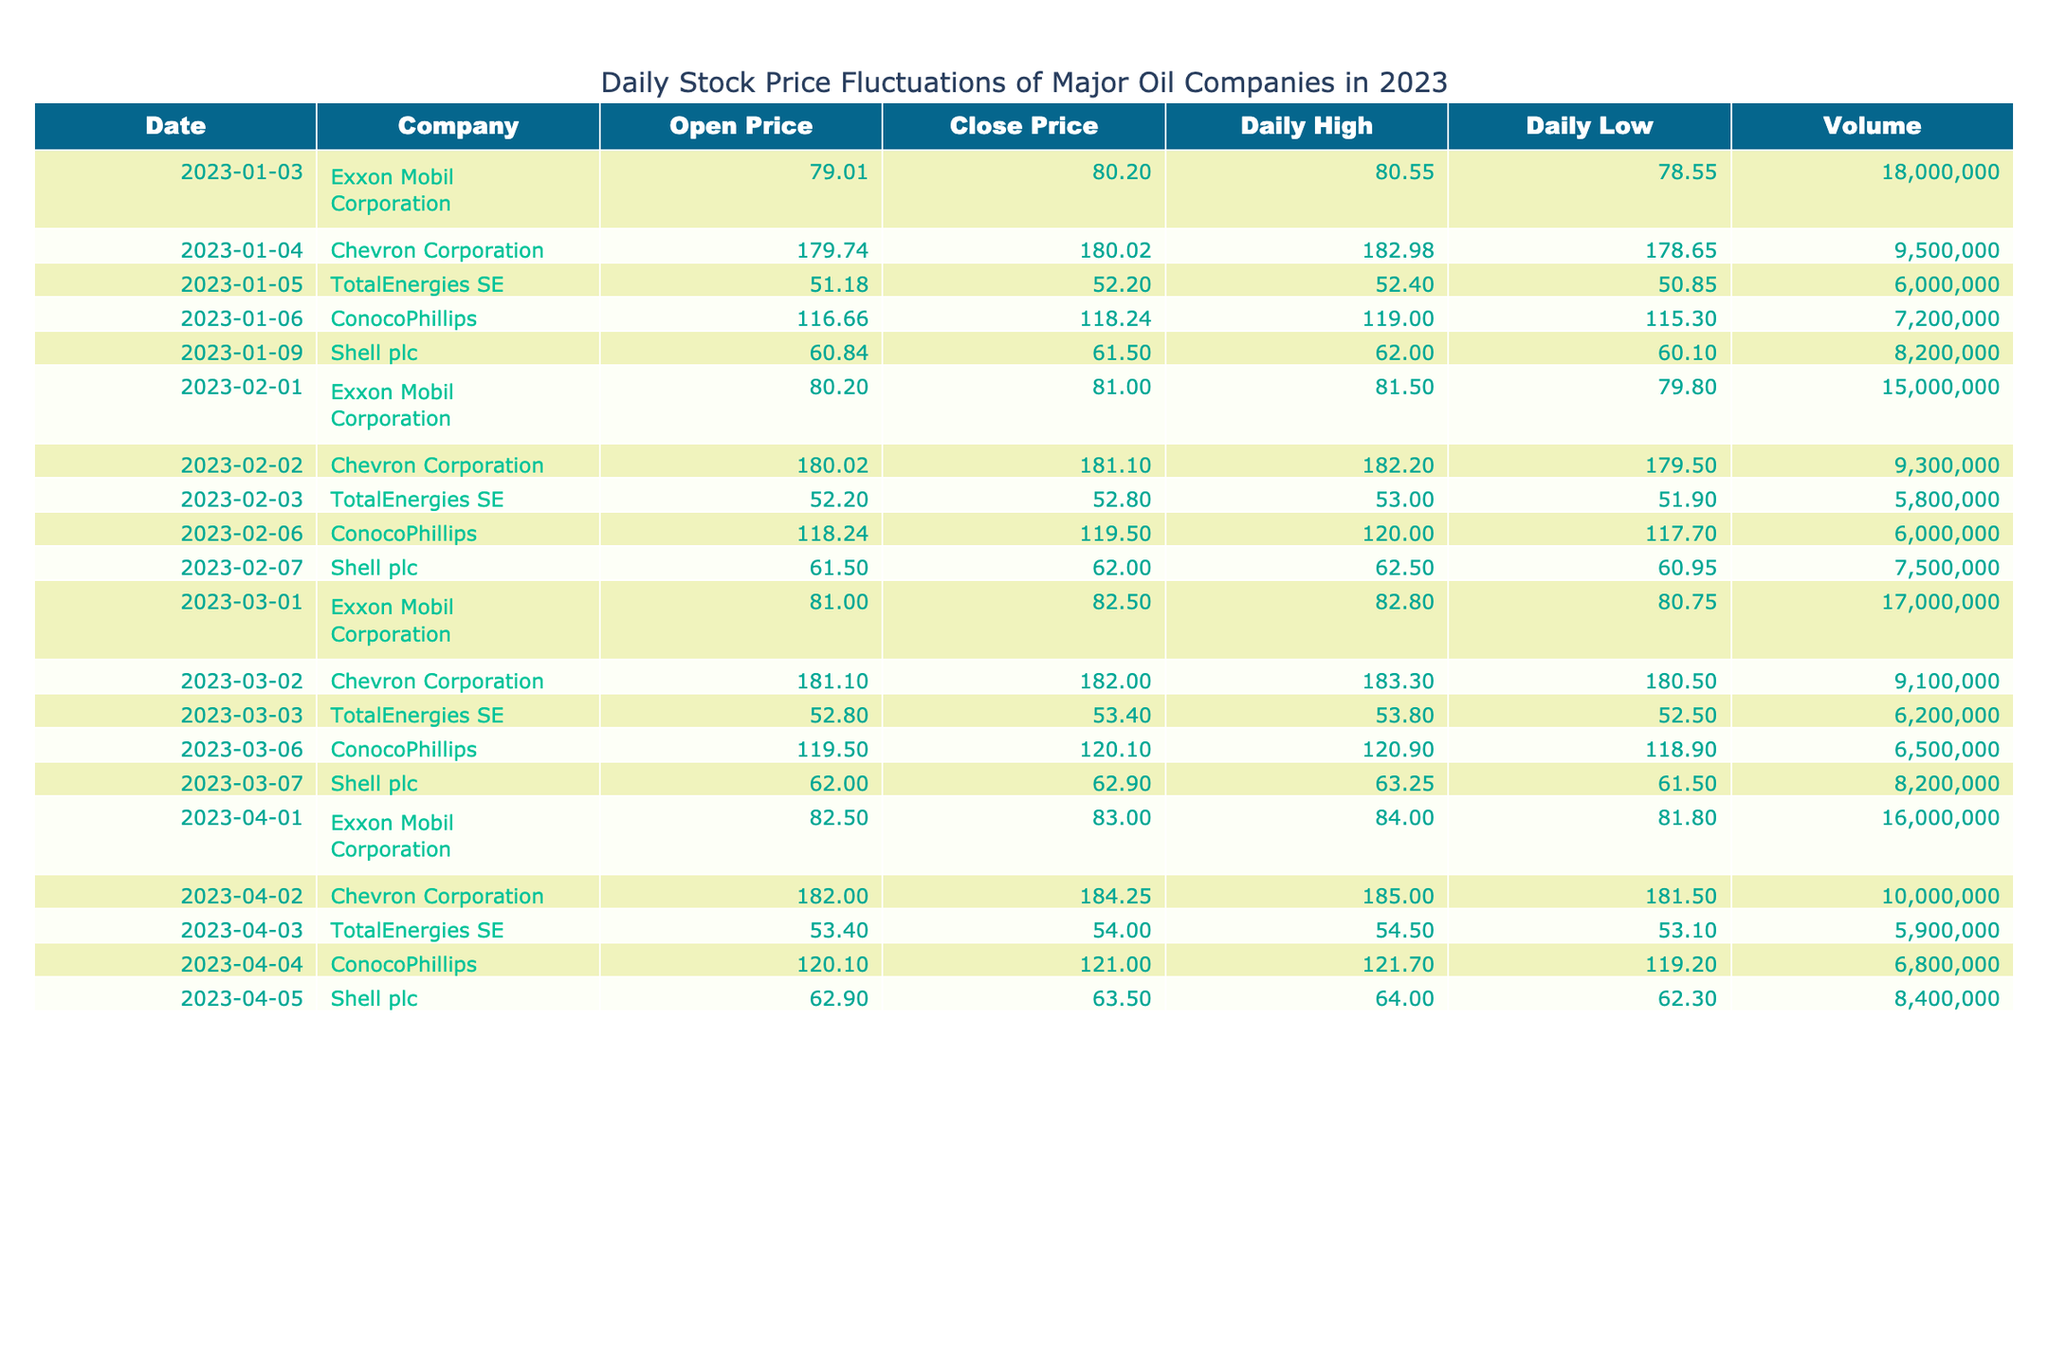What was the closing price for Chevron Corporation on February 2, 2023? The table shows that the closing price for Chevron Corporation on February 2, 2023, is listed in the "Close Price" column alongside the corresponding date and company name. By locating the row for Chevron Corporation on that date, we find the value of 181.10.
Answer: 181.10 What is the daily high price for TotalEnergies SE on April 3, 2023? The table provides a specific row for TotalEnergies SE on April 3, 2023, where the "Daily High" column is accessed. The value in that row indicates that the daily high price was 54.50.
Answer: 54.50 Which company had the highest open price on January 4, 2023? The table shows that on January 4, 2023, the only company listed is Chevron Corporation, with an open price of 179.74. Since it’s the only entry for that date, it is automatically the highest.
Answer: Chevron Corporation What is the average closing price for Shell plc in the recorded dates? To calculate the average closing price for Shell plc, we need to first find all closing prices from the table. There are three entries for Shell plc: 61.50, 62.00, 63.50. Then we sum these values: 61.50 + 62.00 + 63.50 = 187.00. Next, we divide by the number of entries (3), resulting in 187.00 / 3 = 62.33.
Answer: 62.33 Did Exxon Mobil Corporation have a higher opening price on March 1, 2023, compared to its opening price on February 1, 2023? By examining the opening prices for Exxon Mobil Corporation, we find that on March 1, 2023, the opening price was 81.00, and on February 1, 2023, it was 80.20. Therefore, 81.00 is greater than 80.20, confirming that it had a higher opening price in March.
Answer: Yes What was the total volume of shares traded for ConocoPhillips across all recorded dates? We need to sum the volume of shares traded for ConocoPhillips across the rows in the table: 7,200,000 + 6,000,000 + 6,500,000 + 6,800,000 = 26,500,000. This total provides a comprehensive view of all transactions.
Answer: 26,500,000 How many days did TotalEnergies SE have a closing price above 53.00? We need to review the closing prices for TotalEnergies SE from the table: The closing prices are 52.20, 52.80, 53.40, and 54.00. Out of these, two closing prices (53.40 and 54.00) are above 53.00. Thus, TotalEnergies SE had two days with closing prices above this threshold.
Answer: 2 What was the lowest daily low price recorded for Exxon Mobil Corporation in 2023? We search for the daily low prices associated with Exxon Mobil Corporation across all listed dates. The values are 78.55, 79.80, 80.75, and 81.80. The lowest of these prices is 78.55, indicating the lowest daily low price for that company in the year.
Answer: 78.55 